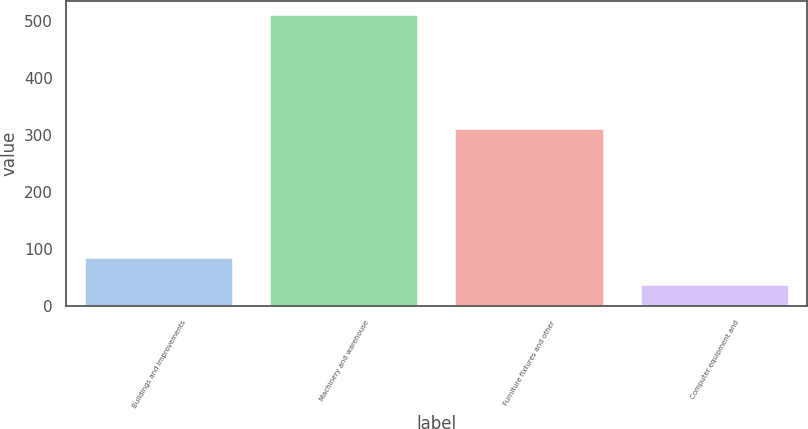Convert chart to OTSL. <chart><loc_0><loc_0><loc_500><loc_500><bar_chart><fcel>Buildings and improvements<fcel>Machinery and warehouse<fcel>Furniture fixtures and other<fcel>Computer equipment and<nl><fcel>85.2<fcel>510<fcel>310<fcel>38<nl></chart> 